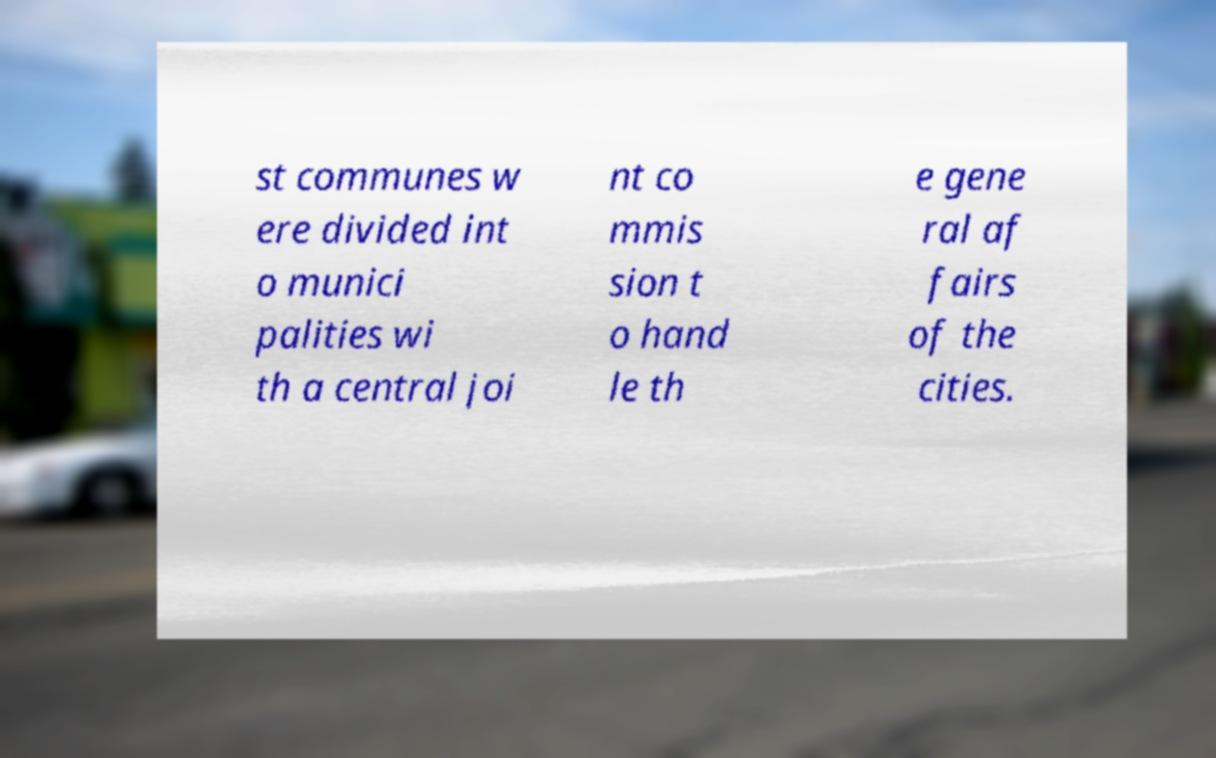I need the written content from this picture converted into text. Can you do that? st communes w ere divided int o munici palities wi th a central joi nt co mmis sion t o hand le th e gene ral af fairs of the cities. 